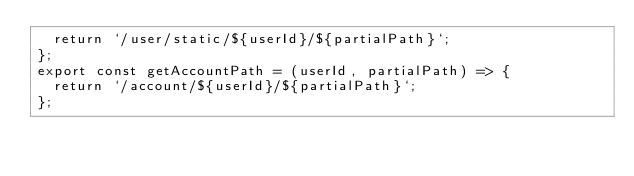<code> <loc_0><loc_0><loc_500><loc_500><_JavaScript_>  return `/user/static/${userId}/${partialPath}`;
};
export const getAccountPath = (userId, partialPath) => {
  return `/account/${userId}/${partialPath}`;
};
</code> 